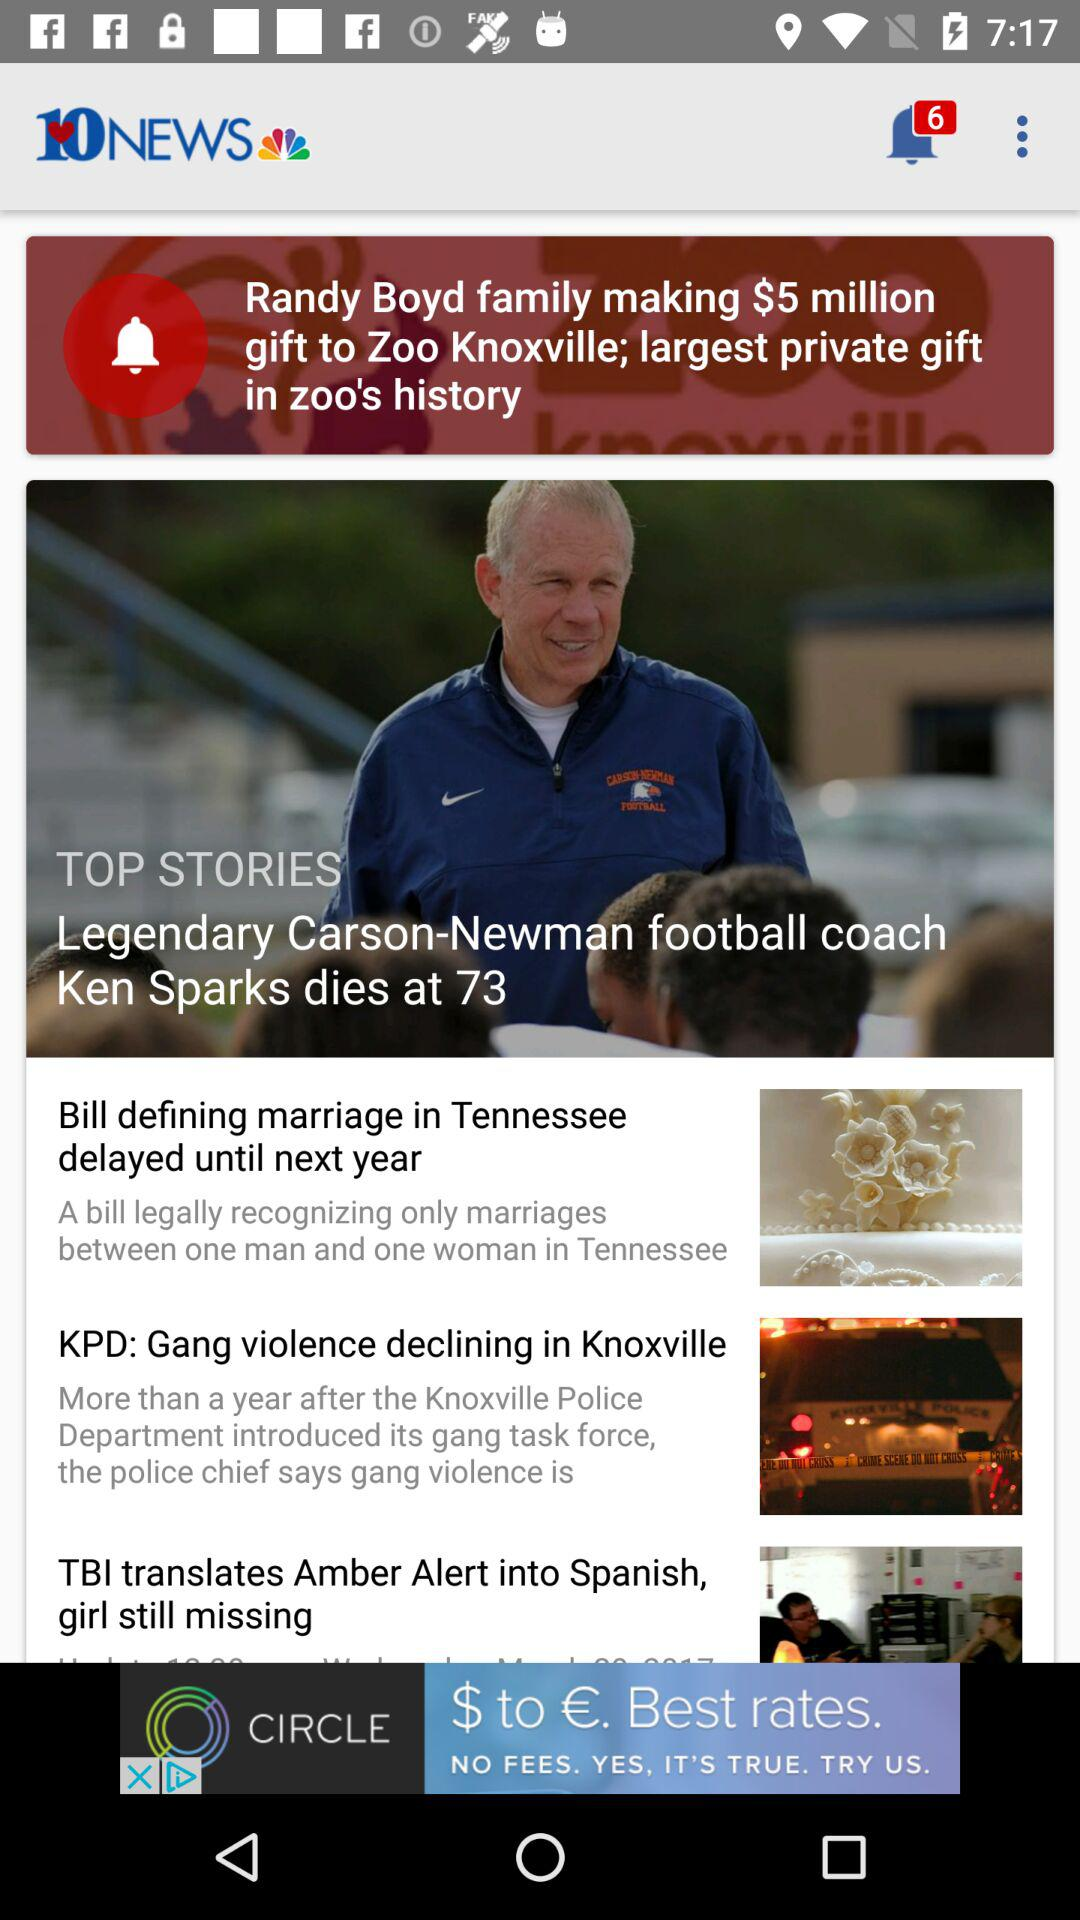When was "Legendary Carson-Newman football coach Ken Sparks dies at 73" posted?
When the provided information is insufficient, respond with <no answer>. <no answer> 